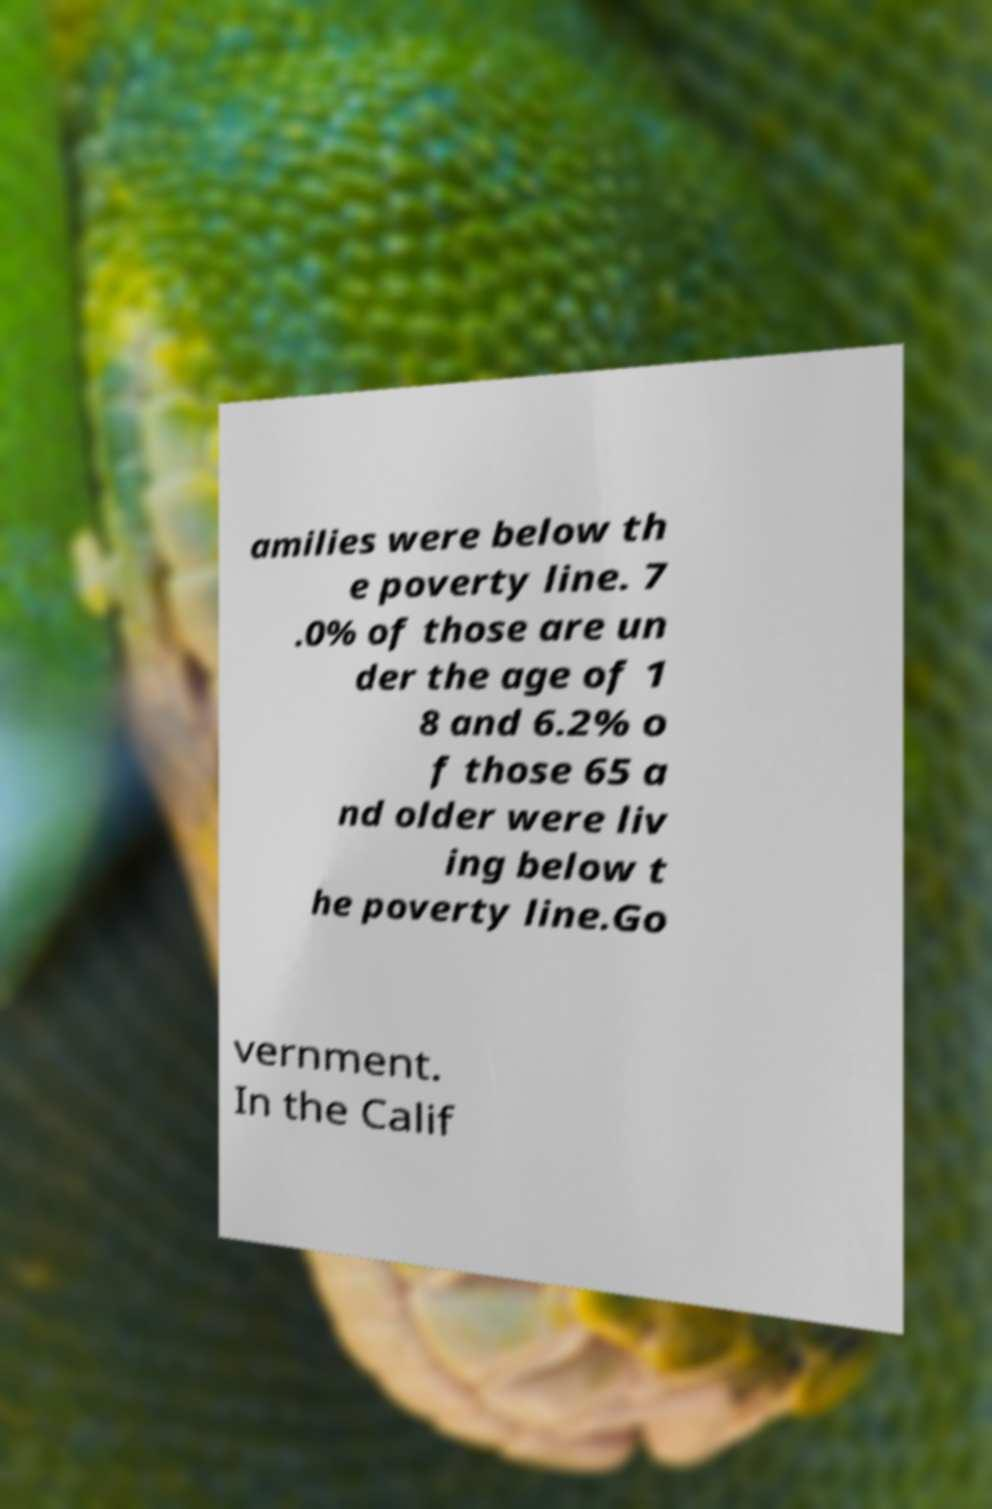Can you accurately transcribe the text from the provided image for me? amilies were below th e poverty line. 7 .0% of those are un der the age of 1 8 and 6.2% o f those 65 a nd older were liv ing below t he poverty line.Go vernment. In the Calif 